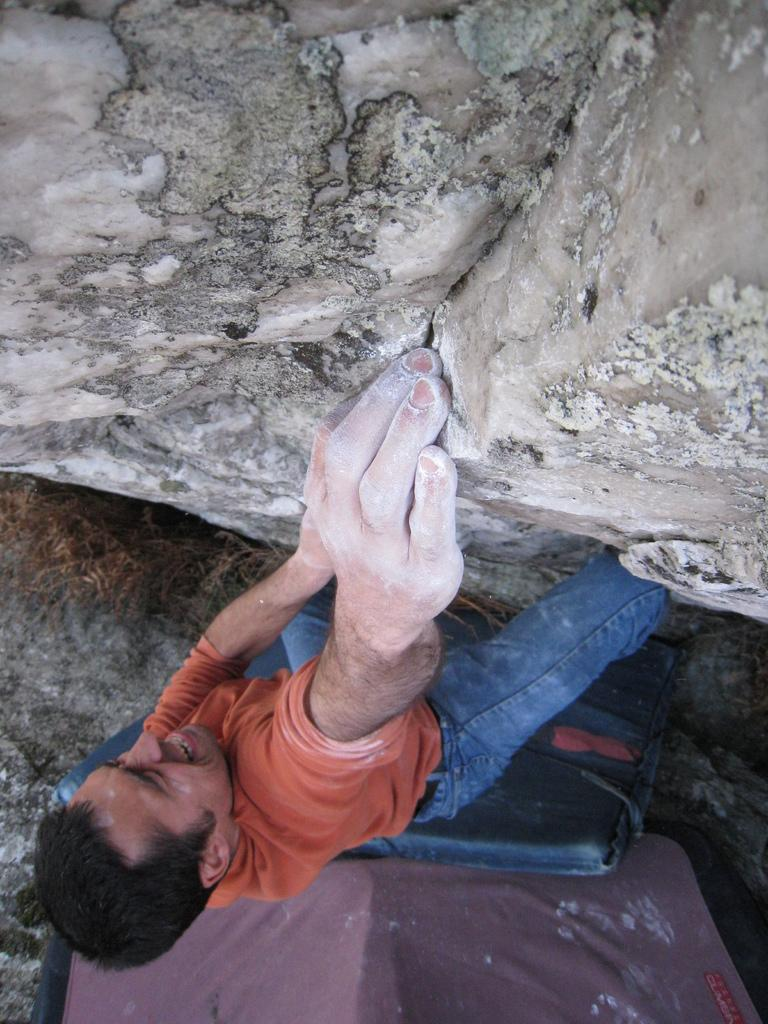Who is the main subject in the image? There is a man in the image. What is the man doing in the image? The man appears to be climbing a rock. What else can be seen at the bottom portion of the image? There are objects visible at the bottom portion of the image. What is the primary geological feature in the image? There is a rock in the image. What type of furniture can be seen in the image? There is no furniture present in the image. How does the bubble affect the man's climbing experience in the image? There is no bubble present in the image, so it does not affect the man's climbing experience. 